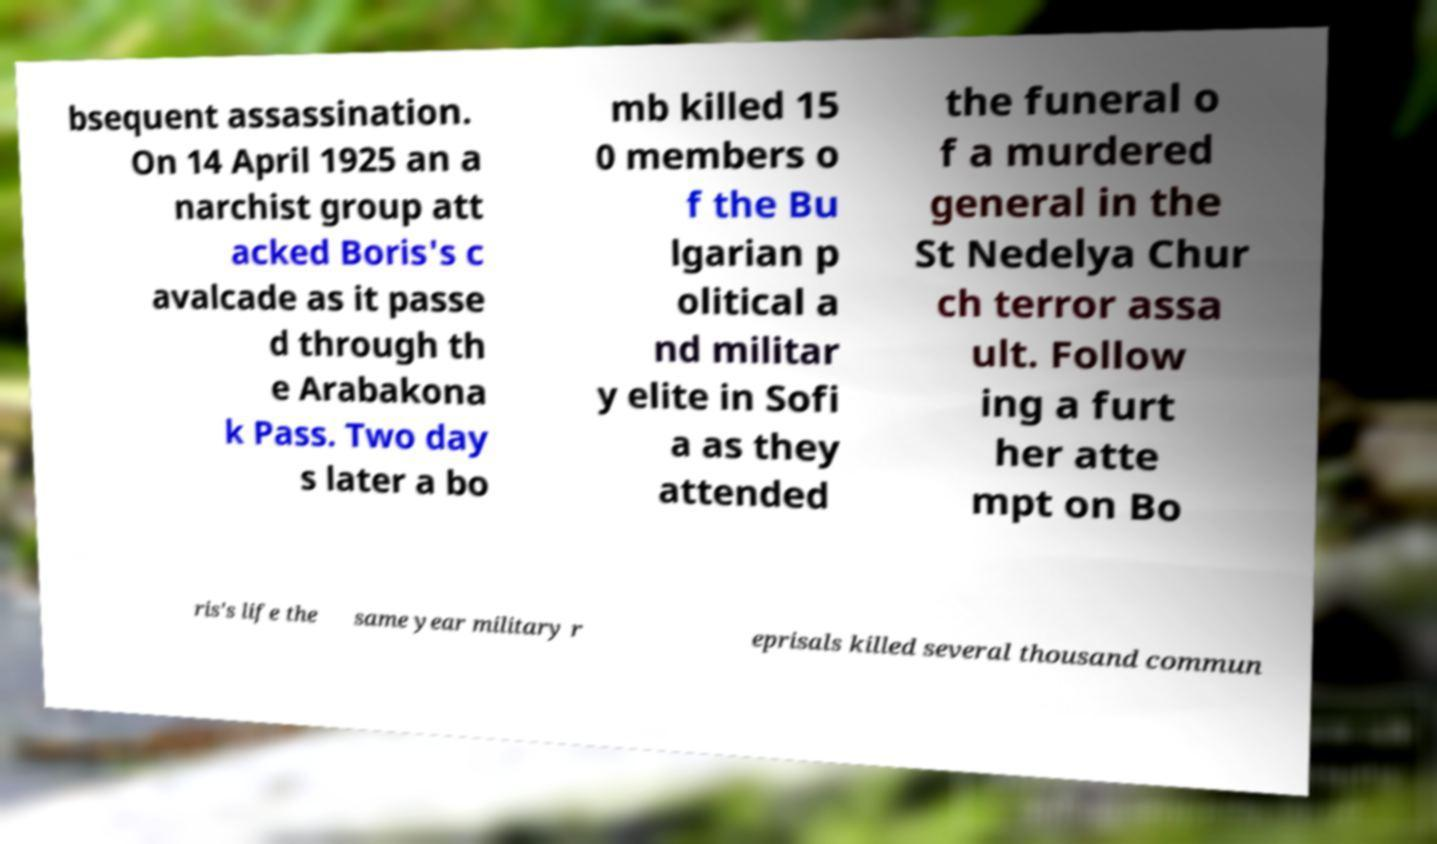I need the written content from this picture converted into text. Can you do that? bsequent assassination. On 14 April 1925 an a narchist group att acked Boris's c avalcade as it passe d through th e Arabakona k Pass. Two day s later a bo mb killed 15 0 members o f the Bu lgarian p olitical a nd militar y elite in Sofi a as they attended the funeral o f a murdered general in the St Nedelya Chur ch terror assa ult. Follow ing a furt her atte mpt on Bo ris's life the same year military r eprisals killed several thousand commun 